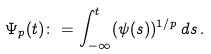<formula> <loc_0><loc_0><loc_500><loc_500>\Psi _ { p } ( t ) \colon = \int _ { - \infty } ^ { t } ( \psi ( s ) ) ^ { 1 / p } \, d s \, .</formula> 